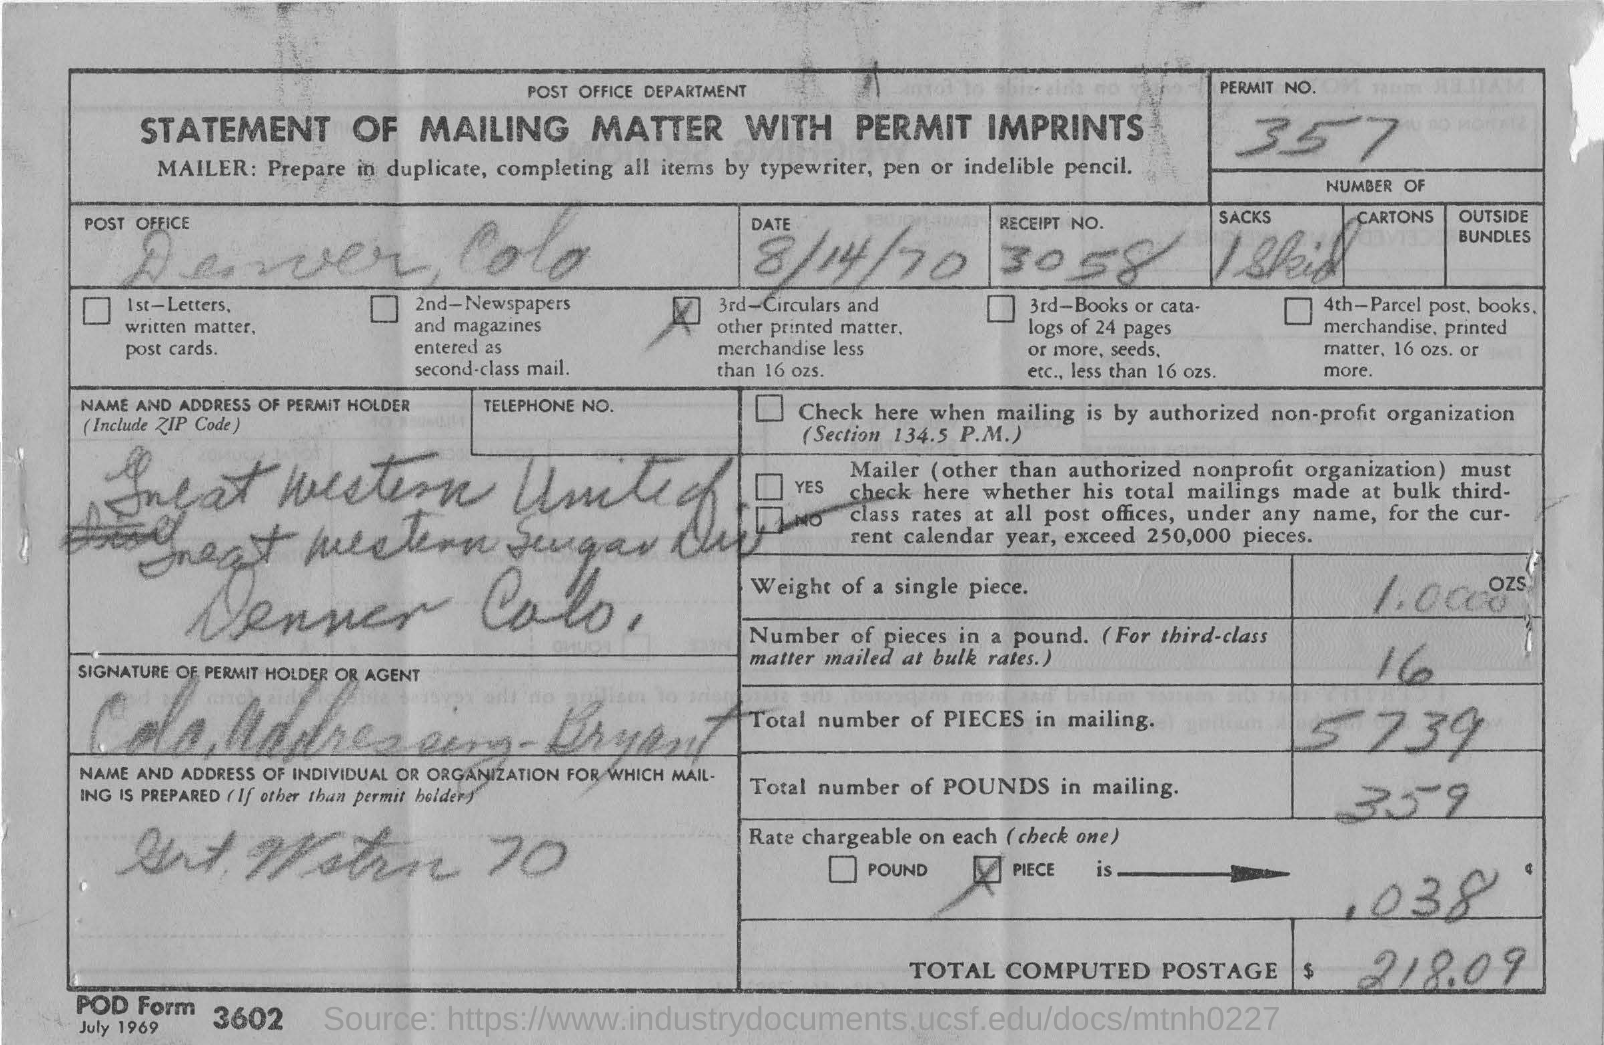What is the permit no.?
Give a very brief answer. 357. What is the document title?
Give a very brief answer. STATEMENT OF MAILING MATTER WITH PERMIT IMPRINTS. What is the date given?
Ensure brevity in your answer.  8/14/70. What is the receipt no.?
Offer a terse response. 3058. What is the total number of PIECES in mailing?
Provide a short and direct response. 5739. What is the amount of total computed postage?
Your answer should be compact. 218.09. 